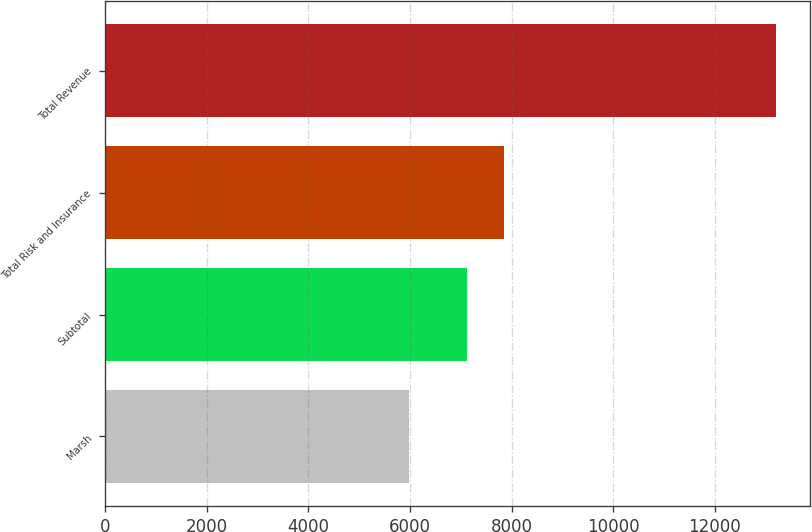Convert chart to OTSL. <chart><loc_0><loc_0><loc_500><loc_500><bar_chart><fcel>Marsh<fcel>Subtotal<fcel>Total Risk and Insurance<fcel>Total Revenue<nl><fcel>5976<fcel>7117<fcel>7840.5<fcel>13211<nl></chart> 